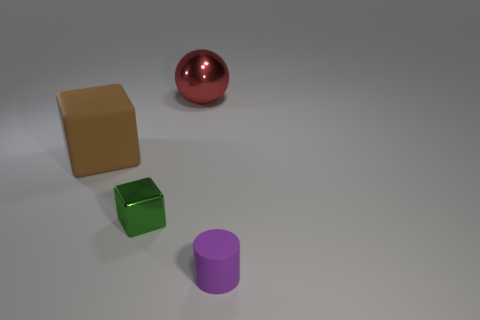Add 2 red objects. How many objects exist? 6 Subtract all cylinders. How many objects are left? 3 Subtract all small shiny blocks. Subtract all large matte cubes. How many objects are left? 2 Add 3 large red balls. How many large red balls are left? 4 Add 2 brown matte cylinders. How many brown matte cylinders exist? 2 Subtract 0 green balls. How many objects are left? 4 